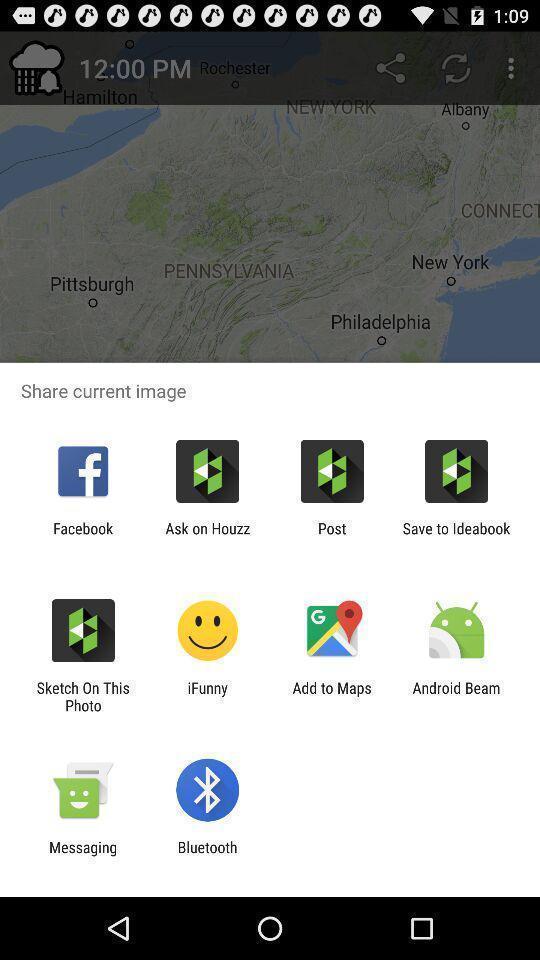Provide a description of this screenshot. Pop-up showing various image sharing options. 